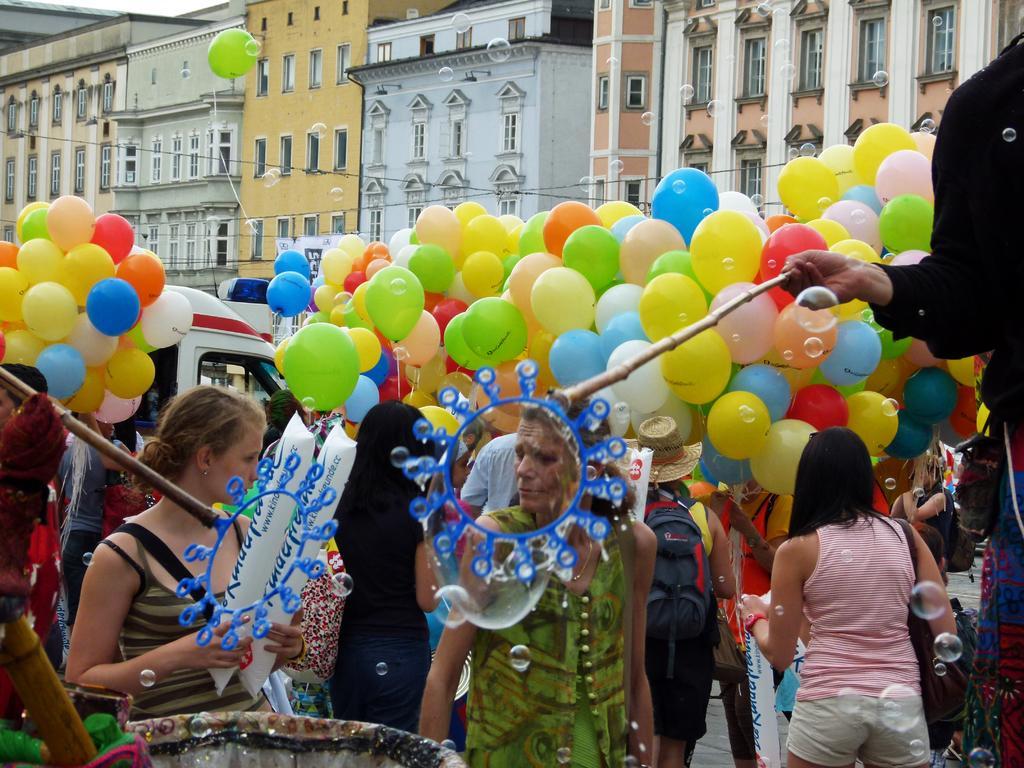Can you describe this image briefly? This is an outside view. At the bottom of the image there are many people on the road. Along with the people I can see many balloons and toys. On the left side there is a vehicle. In the background there are few buildings. 